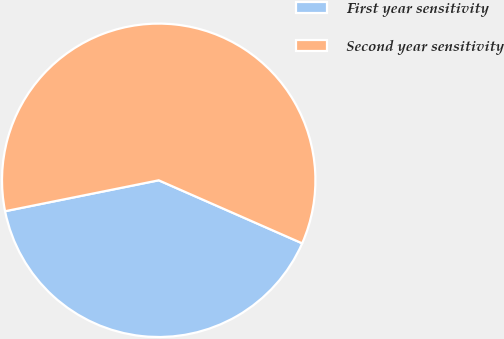<chart> <loc_0><loc_0><loc_500><loc_500><pie_chart><fcel>First year sensitivity<fcel>Second year sensitivity<nl><fcel>40.25%<fcel>59.75%<nl></chart> 